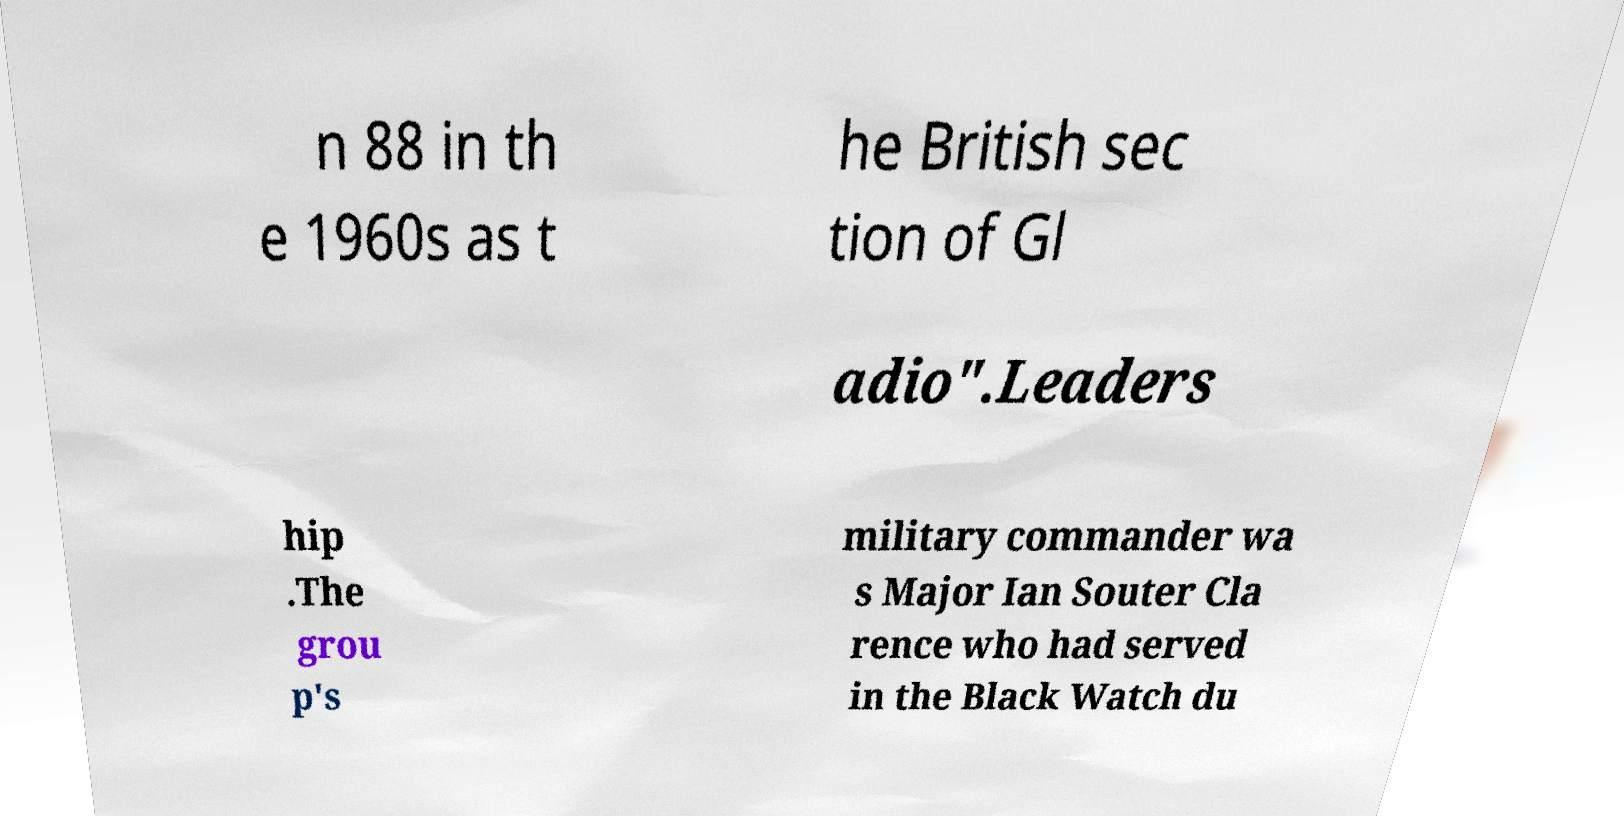For documentation purposes, I need the text within this image transcribed. Could you provide that? n 88 in th e 1960s as t he British sec tion of Gl adio".Leaders hip .The grou p's military commander wa s Major Ian Souter Cla rence who had served in the Black Watch du 